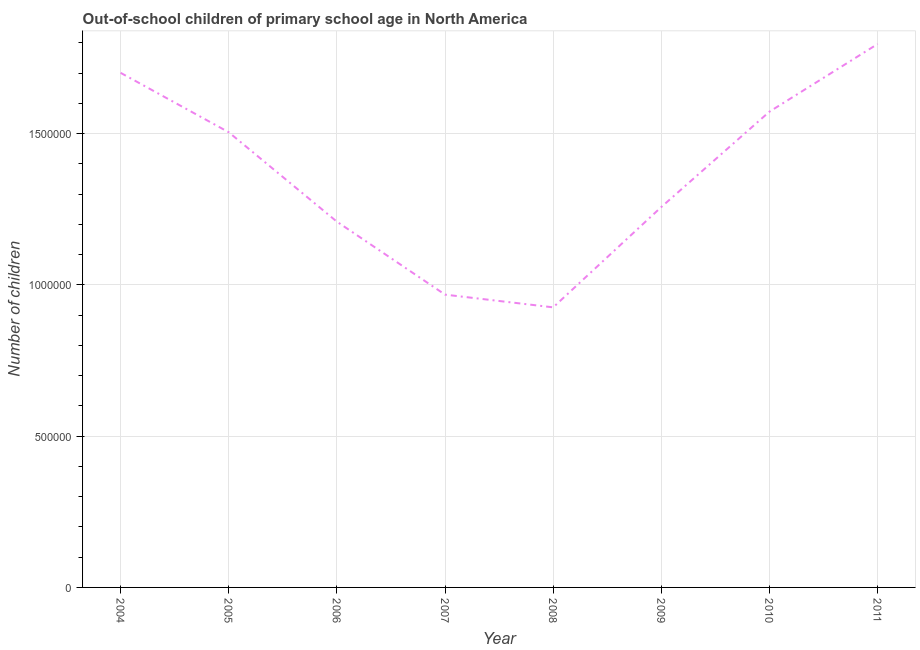What is the number of out-of-school children in 2006?
Keep it short and to the point. 1.21e+06. Across all years, what is the maximum number of out-of-school children?
Provide a short and direct response. 1.80e+06. Across all years, what is the minimum number of out-of-school children?
Provide a short and direct response. 9.26e+05. In which year was the number of out-of-school children minimum?
Offer a very short reply. 2008. What is the sum of the number of out-of-school children?
Offer a very short reply. 1.09e+07. What is the difference between the number of out-of-school children in 2004 and 2010?
Your answer should be compact. 1.28e+05. What is the average number of out-of-school children per year?
Ensure brevity in your answer.  1.37e+06. What is the median number of out-of-school children?
Your answer should be very brief. 1.38e+06. In how many years, is the number of out-of-school children greater than 700000 ?
Your response must be concise. 8. Do a majority of the years between 2007 and 2008 (inclusive) have number of out-of-school children greater than 100000 ?
Offer a very short reply. Yes. What is the ratio of the number of out-of-school children in 2004 to that in 2008?
Your answer should be very brief. 1.84. Is the number of out-of-school children in 2005 less than that in 2010?
Offer a very short reply. Yes. Is the difference between the number of out-of-school children in 2008 and 2009 greater than the difference between any two years?
Make the answer very short. No. What is the difference between the highest and the second highest number of out-of-school children?
Your answer should be very brief. 9.52e+04. Is the sum of the number of out-of-school children in 2004 and 2006 greater than the maximum number of out-of-school children across all years?
Ensure brevity in your answer.  Yes. What is the difference between the highest and the lowest number of out-of-school children?
Provide a short and direct response. 8.70e+05. Does the number of out-of-school children monotonically increase over the years?
Your answer should be compact. No. How many years are there in the graph?
Provide a succinct answer. 8. Does the graph contain grids?
Ensure brevity in your answer.  Yes. What is the title of the graph?
Provide a succinct answer. Out-of-school children of primary school age in North America. What is the label or title of the X-axis?
Keep it short and to the point. Year. What is the label or title of the Y-axis?
Ensure brevity in your answer.  Number of children. What is the Number of children in 2004?
Offer a terse response. 1.70e+06. What is the Number of children in 2005?
Provide a succinct answer. 1.50e+06. What is the Number of children of 2006?
Your answer should be compact. 1.21e+06. What is the Number of children in 2007?
Offer a terse response. 9.68e+05. What is the Number of children of 2008?
Ensure brevity in your answer.  9.26e+05. What is the Number of children in 2009?
Provide a short and direct response. 1.26e+06. What is the Number of children in 2010?
Give a very brief answer. 1.57e+06. What is the Number of children in 2011?
Your answer should be very brief. 1.80e+06. What is the difference between the Number of children in 2004 and 2005?
Your answer should be very brief. 1.96e+05. What is the difference between the Number of children in 2004 and 2006?
Provide a succinct answer. 4.92e+05. What is the difference between the Number of children in 2004 and 2007?
Your answer should be compact. 7.33e+05. What is the difference between the Number of children in 2004 and 2008?
Provide a succinct answer. 7.75e+05. What is the difference between the Number of children in 2004 and 2009?
Keep it short and to the point. 4.43e+05. What is the difference between the Number of children in 2004 and 2010?
Offer a terse response. 1.28e+05. What is the difference between the Number of children in 2004 and 2011?
Ensure brevity in your answer.  -9.52e+04. What is the difference between the Number of children in 2005 and 2006?
Offer a very short reply. 2.95e+05. What is the difference between the Number of children in 2005 and 2007?
Your response must be concise. 5.37e+05. What is the difference between the Number of children in 2005 and 2008?
Offer a terse response. 5.79e+05. What is the difference between the Number of children in 2005 and 2009?
Make the answer very short. 2.47e+05. What is the difference between the Number of children in 2005 and 2010?
Offer a terse response. -6.81e+04. What is the difference between the Number of children in 2005 and 2011?
Your answer should be very brief. -2.92e+05. What is the difference between the Number of children in 2006 and 2007?
Offer a terse response. 2.41e+05. What is the difference between the Number of children in 2006 and 2008?
Offer a very short reply. 2.83e+05. What is the difference between the Number of children in 2006 and 2009?
Provide a short and direct response. -4.85e+04. What is the difference between the Number of children in 2006 and 2010?
Your answer should be compact. -3.64e+05. What is the difference between the Number of children in 2006 and 2011?
Offer a very short reply. -5.87e+05. What is the difference between the Number of children in 2007 and 2008?
Offer a very short reply. 4.20e+04. What is the difference between the Number of children in 2007 and 2009?
Ensure brevity in your answer.  -2.90e+05. What is the difference between the Number of children in 2007 and 2010?
Make the answer very short. -6.05e+05. What is the difference between the Number of children in 2007 and 2011?
Provide a short and direct response. -8.28e+05. What is the difference between the Number of children in 2008 and 2009?
Ensure brevity in your answer.  -3.32e+05. What is the difference between the Number of children in 2008 and 2010?
Your answer should be compact. -6.47e+05. What is the difference between the Number of children in 2008 and 2011?
Keep it short and to the point. -8.70e+05. What is the difference between the Number of children in 2009 and 2010?
Ensure brevity in your answer.  -3.15e+05. What is the difference between the Number of children in 2009 and 2011?
Make the answer very short. -5.39e+05. What is the difference between the Number of children in 2010 and 2011?
Keep it short and to the point. -2.24e+05. What is the ratio of the Number of children in 2004 to that in 2005?
Give a very brief answer. 1.13. What is the ratio of the Number of children in 2004 to that in 2006?
Offer a terse response. 1.41. What is the ratio of the Number of children in 2004 to that in 2007?
Offer a terse response. 1.76. What is the ratio of the Number of children in 2004 to that in 2008?
Your answer should be very brief. 1.84. What is the ratio of the Number of children in 2004 to that in 2009?
Provide a succinct answer. 1.35. What is the ratio of the Number of children in 2004 to that in 2010?
Ensure brevity in your answer.  1.08. What is the ratio of the Number of children in 2004 to that in 2011?
Your answer should be compact. 0.95. What is the ratio of the Number of children in 2005 to that in 2006?
Offer a terse response. 1.24. What is the ratio of the Number of children in 2005 to that in 2007?
Ensure brevity in your answer.  1.55. What is the ratio of the Number of children in 2005 to that in 2008?
Give a very brief answer. 1.62. What is the ratio of the Number of children in 2005 to that in 2009?
Ensure brevity in your answer.  1.2. What is the ratio of the Number of children in 2005 to that in 2011?
Ensure brevity in your answer.  0.84. What is the ratio of the Number of children in 2006 to that in 2007?
Offer a terse response. 1.25. What is the ratio of the Number of children in 2006 to that in 2008?
Offer a terse response. 1.31. What is the ratio of the Number of children in 2006 to that in 2009?
Make the answer very short. 0.96. What is the ratio of the Number of children in 2006 to that in 2010?
Your response must be concise. 0.77. What is the ratio of the Number of children in 2006 to that in 2011?
Your answer should be compact. 0.67. What is the ratio of the Number of children in 2007 to that in 2008?
Make the answer very short. 1.04. What is the ratio of the Number of children in 2007 to that in 2009?
Your response must be concise. 0.77. What is the ratio of the Number of children in 2007 to that in 2010?
Provide a succinct answer. 0.61. What is the ratio of the Number of children in 2007 to that in 2011?
Your answer should be compact. 0.54. What is the ratio of the Number of children in 2008 to that in 2009?
Provide a short and direct response. 0.74. What is the ratio of the Number of children in 2008 to that in 2010?
Make the answer very short. 0.59. What is the ratio of the Number of children in 2008 to that in 2011?
Offer a terse response. 0.52. What is the ratio of the Number of children in 2010 to that in 2011?
Keep it short and to the point. 0.88. 